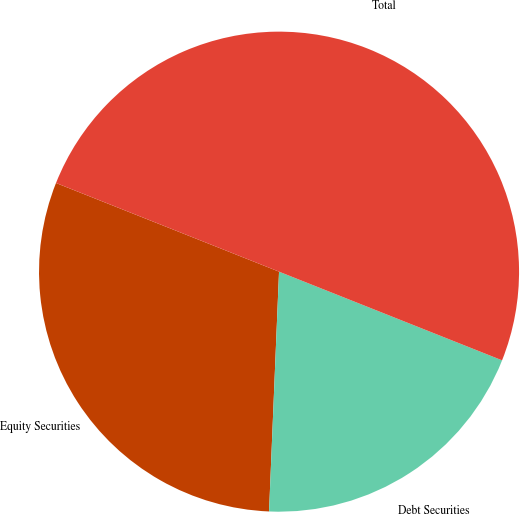<chart> <loc_0><loc_0><loc_500><loc_500><pie_chart><fcel>Equity Securities<fcel>Debt Securities<fcel>Total<nl><fcel>30.36%<fcel>19.64%<fcel>50.0%<nl></chart> 